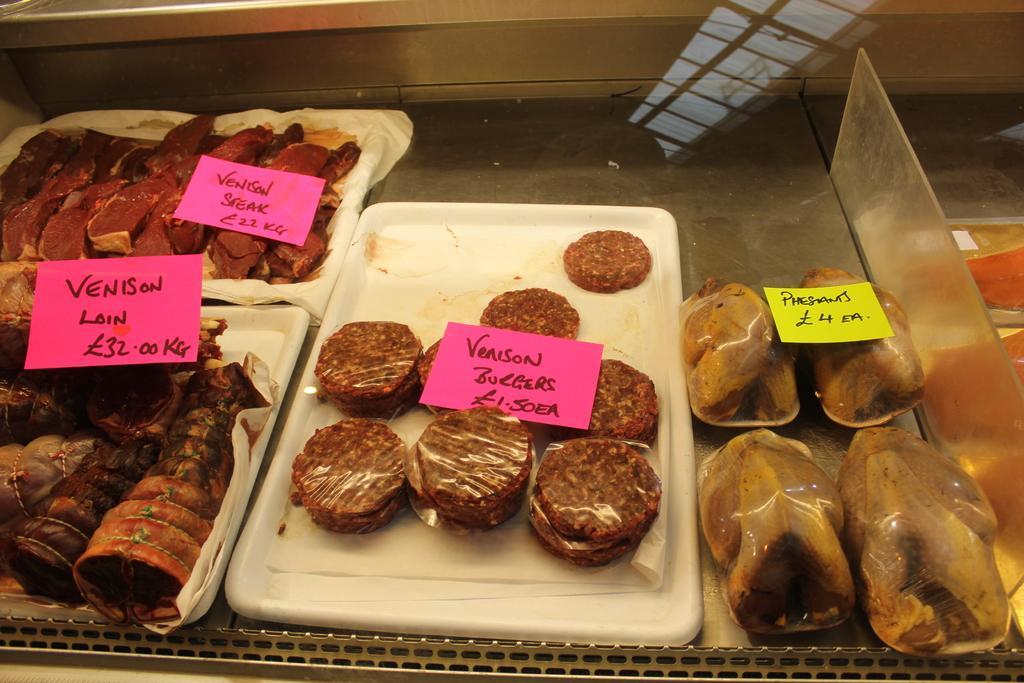Please provide a concise description of this image. In the foreground of this image, there are food items in a tray and on a steel surface. We can also see few price tags and names to it. On the right, there is a glass. 